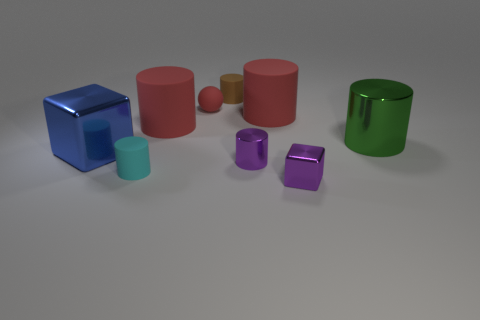Subtract all cyan cylinders. How many cylinders are left? 5 Subtract all purple metal cylinders. How many cylinders are left? 5 Subtract all brown cylinders. Subtract all yellow balls. How many cylinders are left? 5 Add 1 large yellow rubber things. How many objects exist? 10 Subtract all cubes. How many objects are left? 7 Add 5 purple shiny things. How many purple shiny things exist? 7 Subtract 0 blue balls. How many objects are left? 9 Subtract all tiny cubes. Subtract all green things. How many objects are left? 7 Add 7 small spheres. How many small spheres are left? 8 